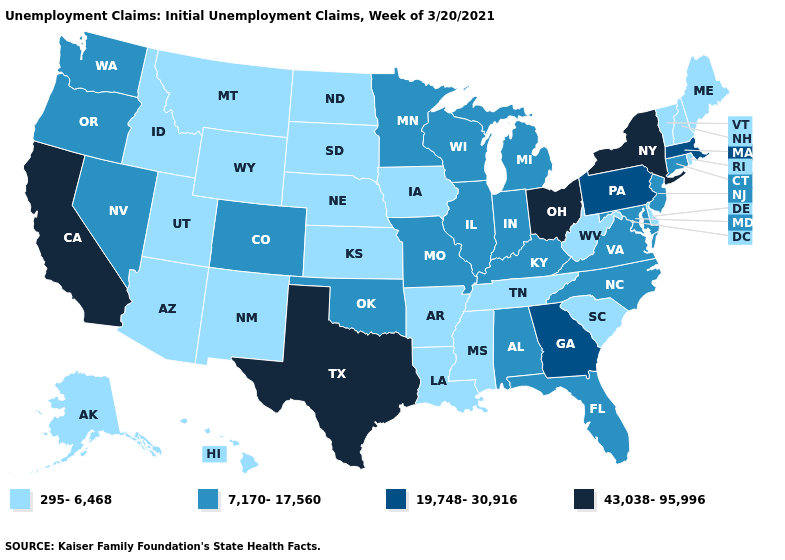What is the highest value in the South ?
Be succinct. 43,038-95,996. Does New Jersey have the same value as South Dakota?
Concise answer only. No. Is the legend a continuous bar?
Keep it brief. No. Does California have the highest value in the West?
Concise answer only. Yes. Among the states that border Tennessee , which have the highest value?
Answer briefly. Georgia. Among the states that border Iowa , which have the lowest value?
Keep it brief. Nebraska, South Dakota. Is the legend a continuous bar?
Give a very brief answer. No. Name the states that have a value in the range 43,038-95,996?
Keep it brief. California, New York, Ohio, Texas. Which states have the highest value in the USA?
Quick response, please. California, New York, Ohio, Texas. Name the states that have a value in the range 19,748-30,916?
Short answer required. Georgia, Massachusetts, Pennsylvania. What is the value of Arizona?
Concise answer only. 295-6,468. Among the states that border Delaware , does Pennsylvania have the lowest value?
Give a very brief answer. No. Does Massachusetts have the lowest value in the Northeast?
Short answer required. No. What is the value of Nevada?
Short answer required. 7,170-17,560. What is the lowest value in states that border Delaware?
Give a very brief answer. 7,170-17,560. 